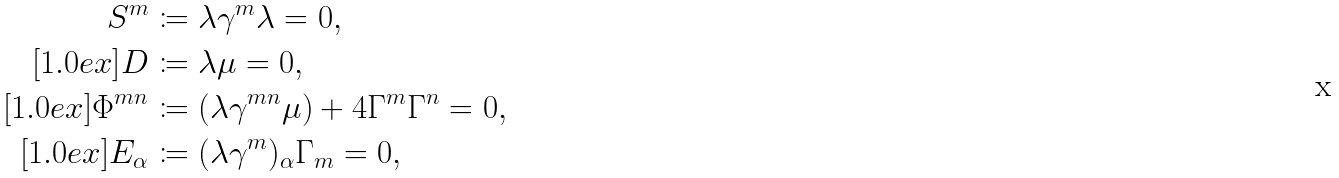Convert formula to latex. <formula><loc_0><loc_0><loc_500><loc_500>S ^ { m } & \coloneqq \lambda \gamma ^ { m } \lambda = 0 , \\ [ 1 . 0 e x ] D & \coloneqq \lambda \mu = 0 , \\ [ 1 . 0 e x ] \Phi ^ { m n } & \coloneqq ( \lambda \gamma ^ { m n } \mu ) + 4 \Gamma ^ { m } \Gamma ^ { n } = 0 , \\ [ 1 . 0 e x ] E _ { \alpha } & \coloneqq ( \lambda \gamma ^ { m } ) _ { \alpha } \Gamma _ { m } = 0 ,</formula> 